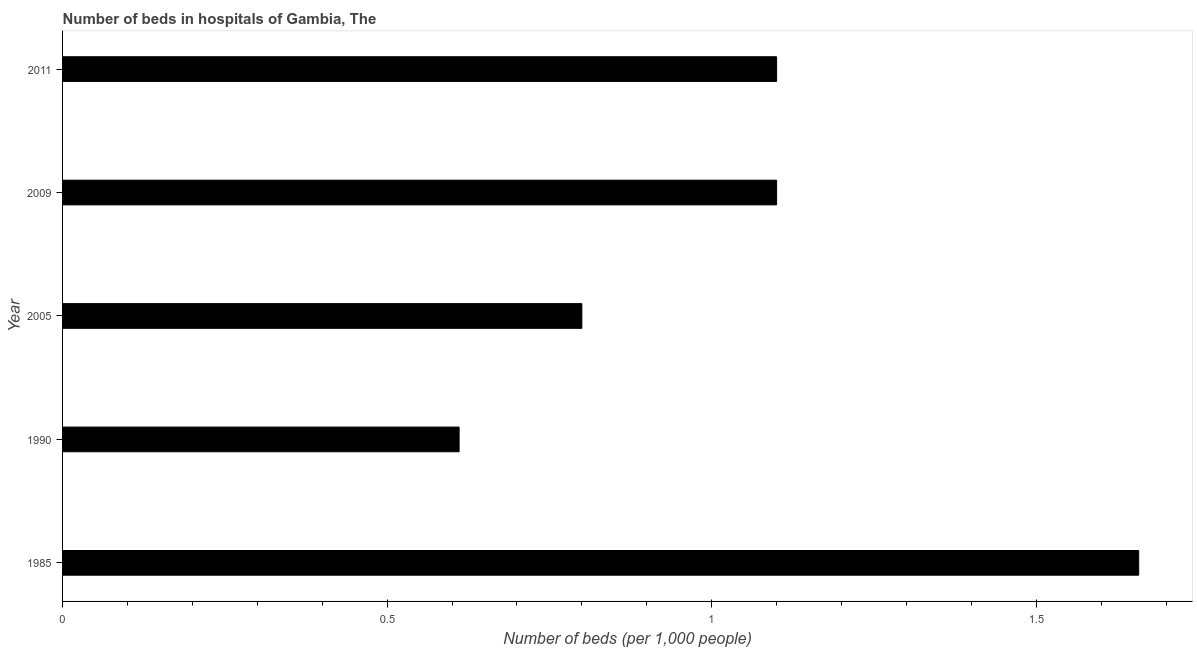Does the graph contain any zero values?
Give a very brief answer. No. What is the title of the graph?
Offer a terse response. Number of beds in hospitals of Gambia, The. What is the label or title of the X-axis?
Give a very brief answer. Number of beds (per 1,0 people). What is the number of hospital beds in 1985?
Give a very brief answer. 1.66. Across all years, what is the maximum number of hospital beds?
Your response must be concise. 1.66. Across all years, what is the minimum number of hospital beds?
Your answer should be very brief. 0.61. In which year was the number of hospital beds maximum?
Keep it short and to the point. 1985. In which year was the number of hospital beds minimum?
Provide a short and direct response. 1990. What is the sum of the number of hospital beds?
Your answer should be very brief. 5.27. What is the average number of hospital beds per year?
Your answer should be compact. 1.05. What is the median number of hospital beds?
Offer a very short reply. 1.1. What is the ratio of the number of hospital beds in 1985 to that in 2005?
Your answer should be very brief. 2.07. Is the difference between the number of hospital beds in 1985 and 2011 greater than the difference between any two years?
Provide a succinct answer. No. What is the difference between the highest and the second highest number of hospital beds?
Your answer should be very brief. 0.56. What is the difference between the highest and the lowest number of hospital beds?
Your answer should be compact. 1.05. In how many years, is the number of hospital beds greater than the average number of hospital beds taken over all years?
Offer a very short reply. 3. How many bars are there?
Keep it short and to the point. 5. What is the Number of beds (per 1,000 people) of 1985?
Give a very brief answer. 1.66. What is the Number of beds (per 1,000 people) of 1990?
Provide a succinct answer. 0.61. What is the Number of beds (per 1,000 people) in 2011?
Offer a terse response. 1.1. What is the difference between the Number of beds (per 1,000 people) in 1985 and 1990?
Offer a very short reply. 1.05. What is the difference between the Number of beds (per 1,000 people) in 1985 and 2005?
Provide a succinct answer. 0.86. What is the difference between the Number of beds (per 1,000 people) in 1985 and 2009?
Offer a very short reply. 0.56. What is the difference between the Number of beds (per 1,000 people) in 1985 and 2011?
Offer a very short reply. 0.56. What is the difference between the Number of beds (per 1,000 people) in 1990 and 2005?
Offer a very short reply. -0.19. What is the difference between the Number of beds (per 1,000 people) in 1990 and 2009?
Offer a very short reply. -0.49. What is the difference between the Number of beds (per 1,000 people) in 1990 and 2011?
Provide a succinct answer. -0.49. What is the difference between the Number of beds (per 1,000 people) in 2005 and 2011?
Your answer should be compact. -0.3. What is the ratio of the Number of beds (per 1,000 people) in 1985 to that in 1990?
Offer a very short reply. 2.71. What is the ratio of the Number of beds (per 1,000 people) in 1985 to that in 2005?
Provide a short and direct response. 2.07. What is the ratio of the Number of beds (per 1,000 people) in 1985 to that in 2009?
Provide a short and direct response. 1.51. What is the ratio of the Number of beds (per 1,000 people) in 1985 to that in 2011?
Keep it short and to the point. 1.51. What is the ratio of the Number of beds (per 1,000 people) in 1990 to that in 2005?
Offer a very short reply. 0.76. What is the ratio of the Number of beds (per 1,000 people) in 1990 to that in 2009?
Offer a terse response. 0.56. What is the ratio of the Number of beds (per 1,000 people) in 1990 to that in 2011?
Your answer should be very brief. 0.56. What is the ratio of the Number of beds (per 1,000 people) in 2005 to that in 2009?
Keep it short and to the point. 0.73. What is the ratio of the Number of beds (per 1,000 people) in 2005 to that in 2011?
Your answer should be very brief. 0.73. 